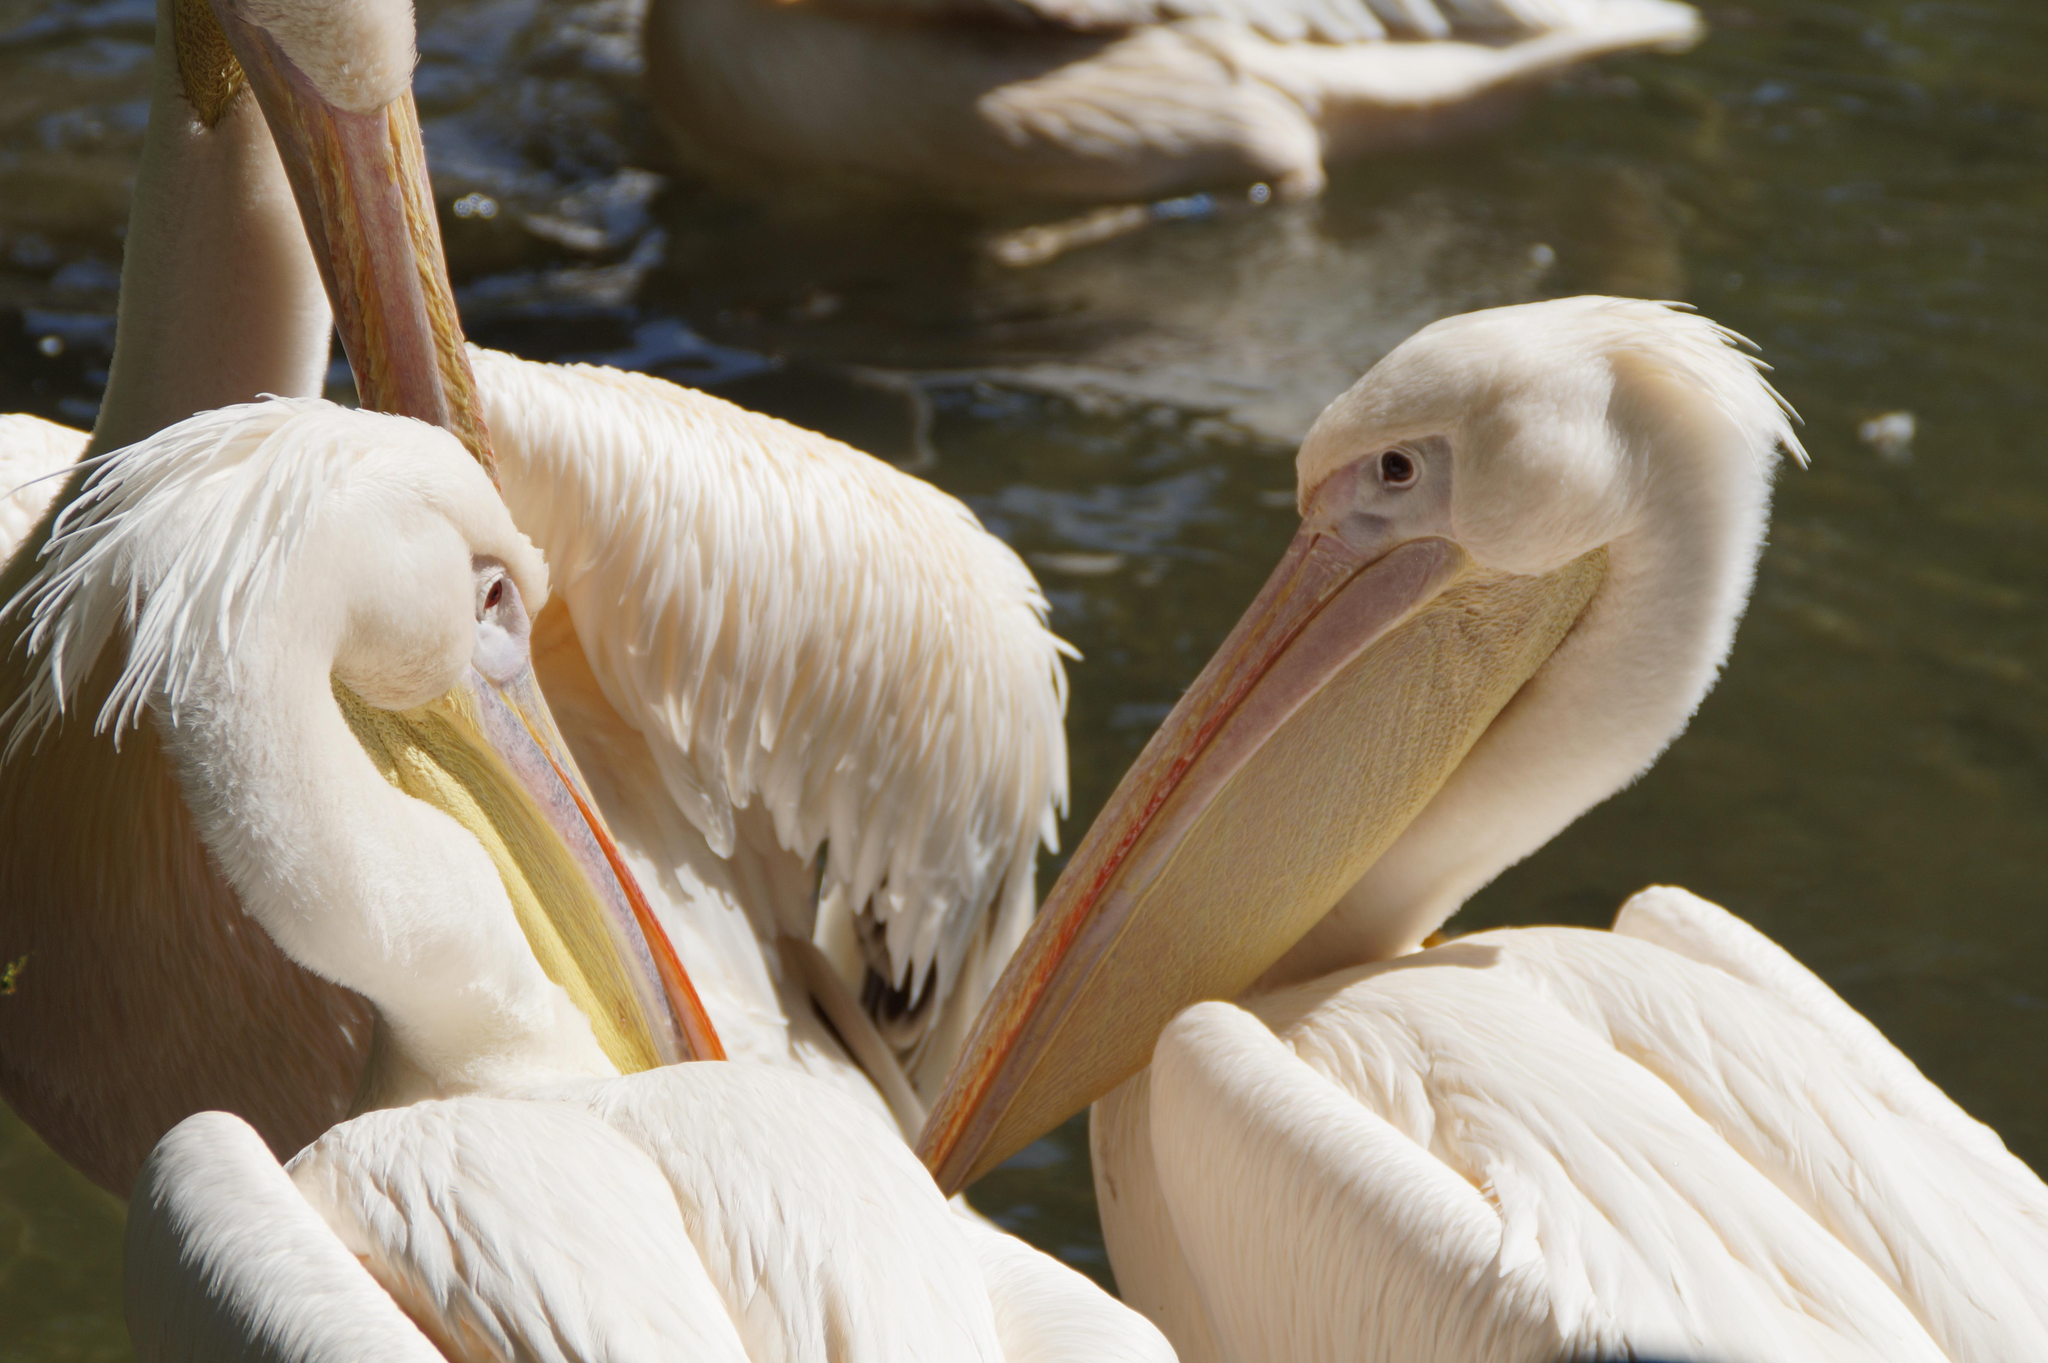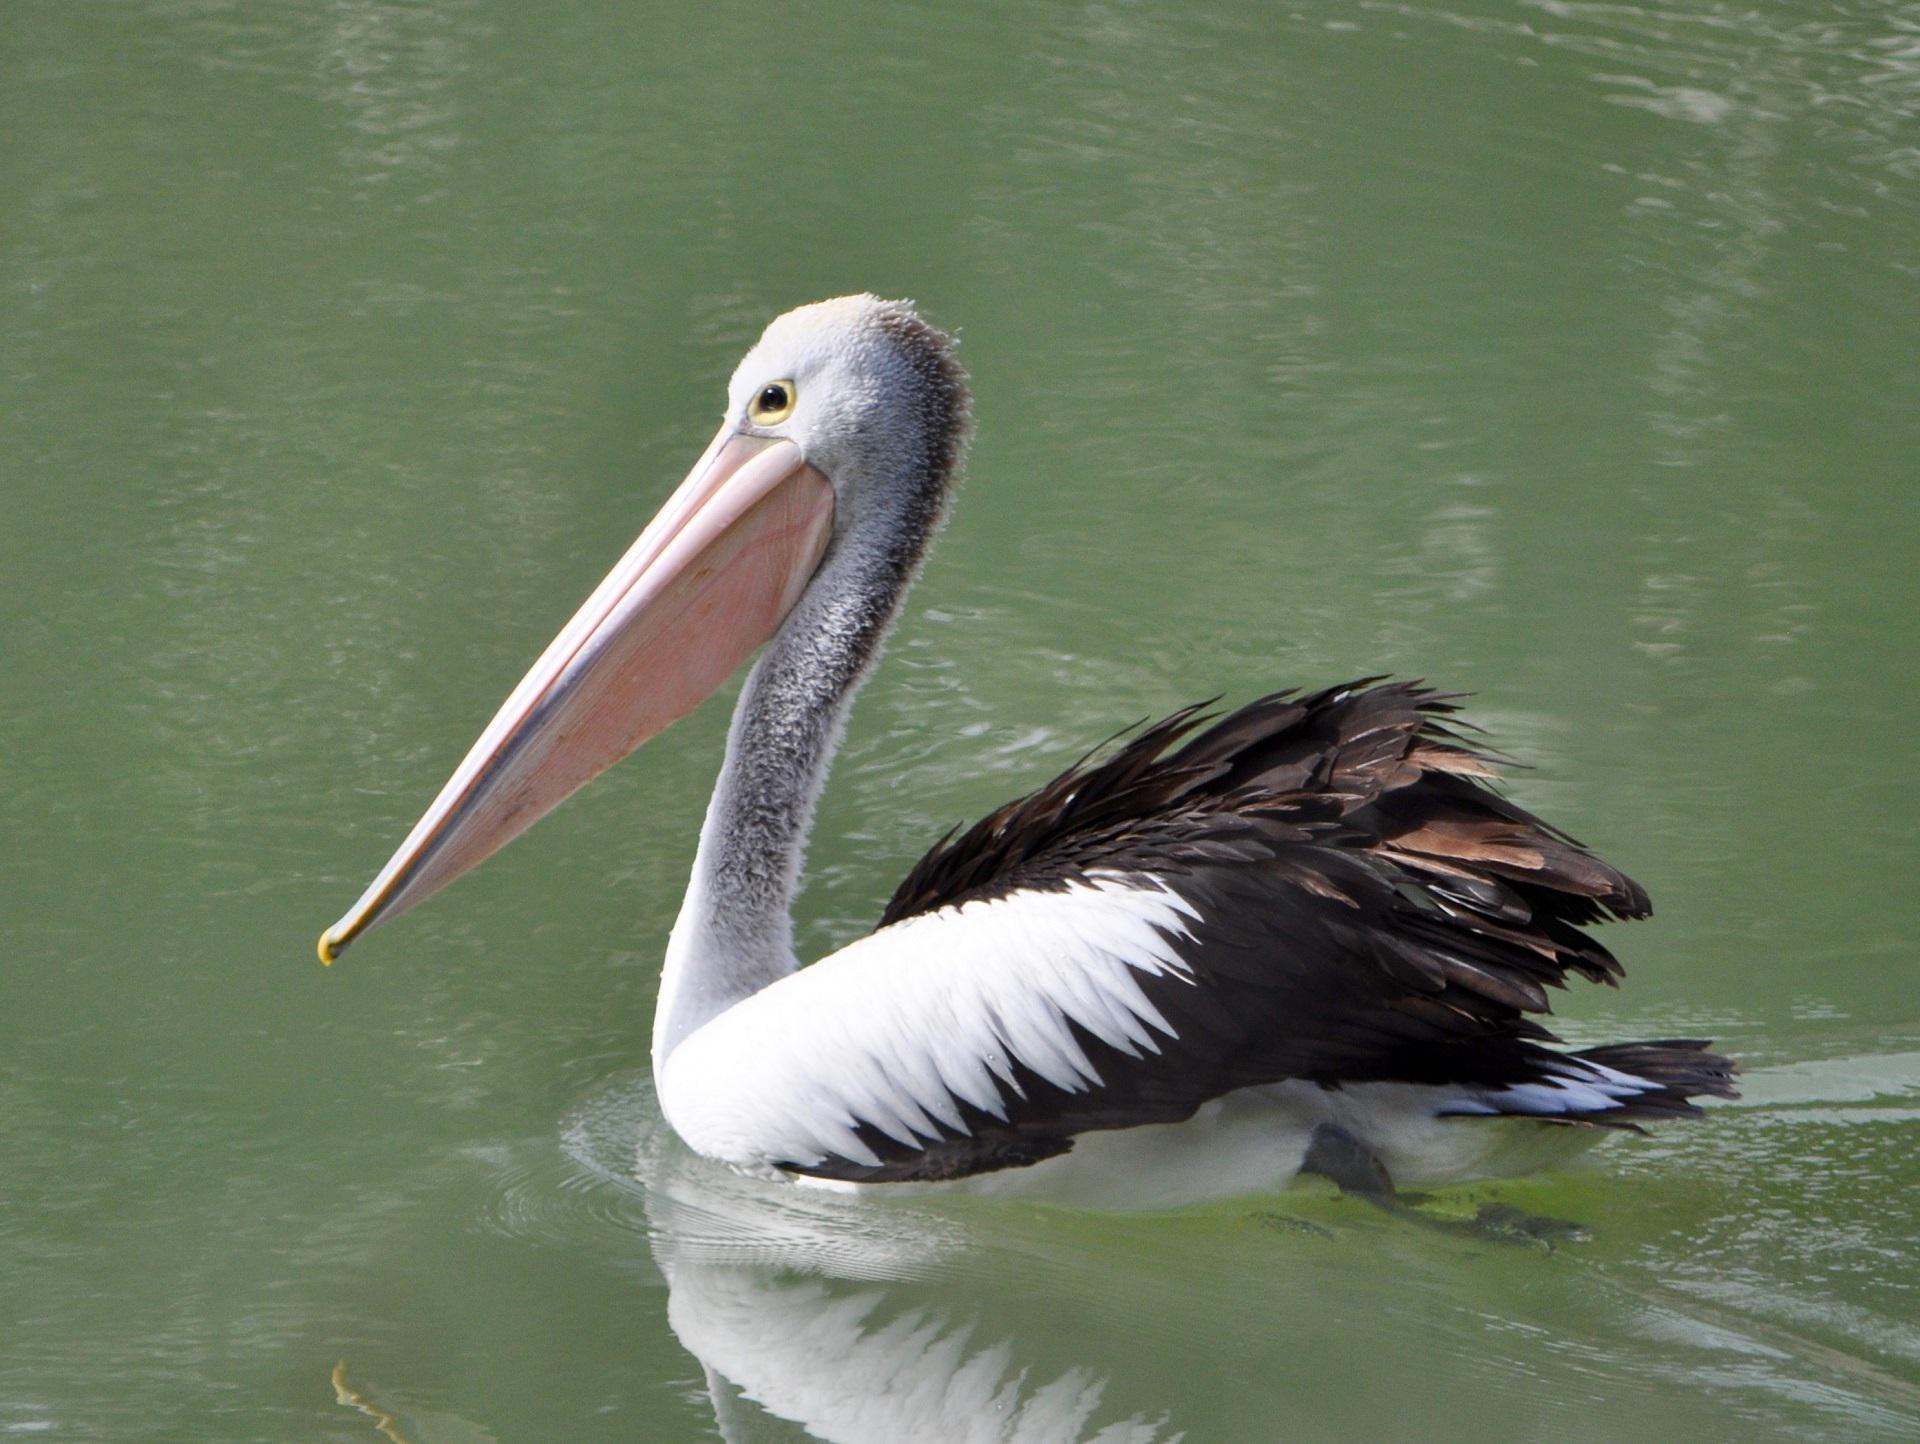The first image is the image on the left, the second image is the image on the right. For the images displayed, is the sentence "One of the birds is sitting on water." factually correct? Answer yes or no. Yes. 